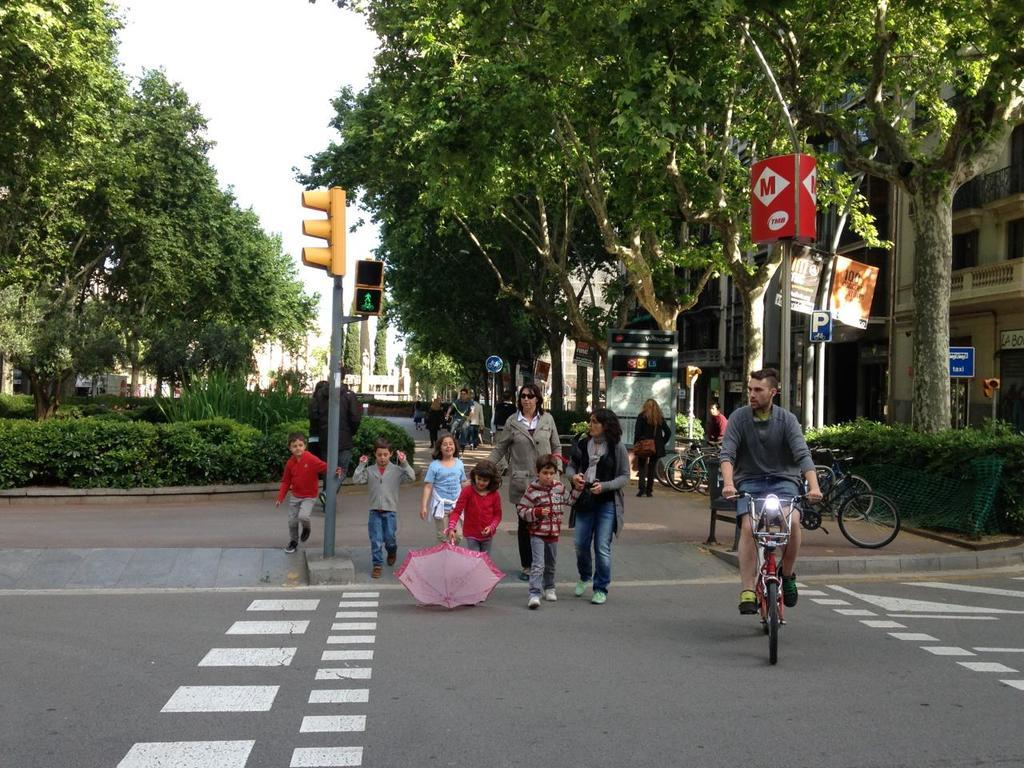<image>
Summarize the visual content of the image. A crowd crossing a street, there is a red sign with an M on it in the upper corner. 